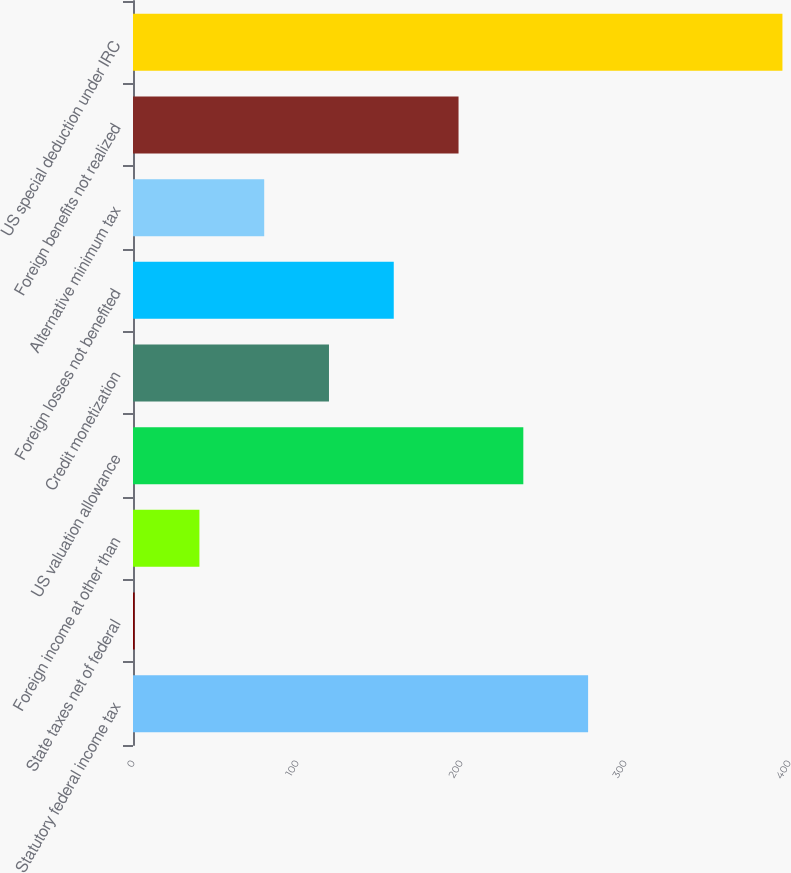Convert chart. <chart><loc_0><loc_0><loc_500><loc_500><bar_chart><fcel>Statutory federal income tax<fcel>State taxes net of federal<fcel>Foreign income at other than<fcel>US valuation allowance<fcel>Credit monetization<fcel>Foreign losses not benefited<fcel>Alternative minimum tax<fcel>Foreign benefits not realized<fcel>US special deduction under IRC<nl><fcel>277.5<fcel>1<fcel>40.5<fcel>238<fcel>119.5<fcel>159<fcel>80<fcel>198.5<fcel>396<nl></chart> 